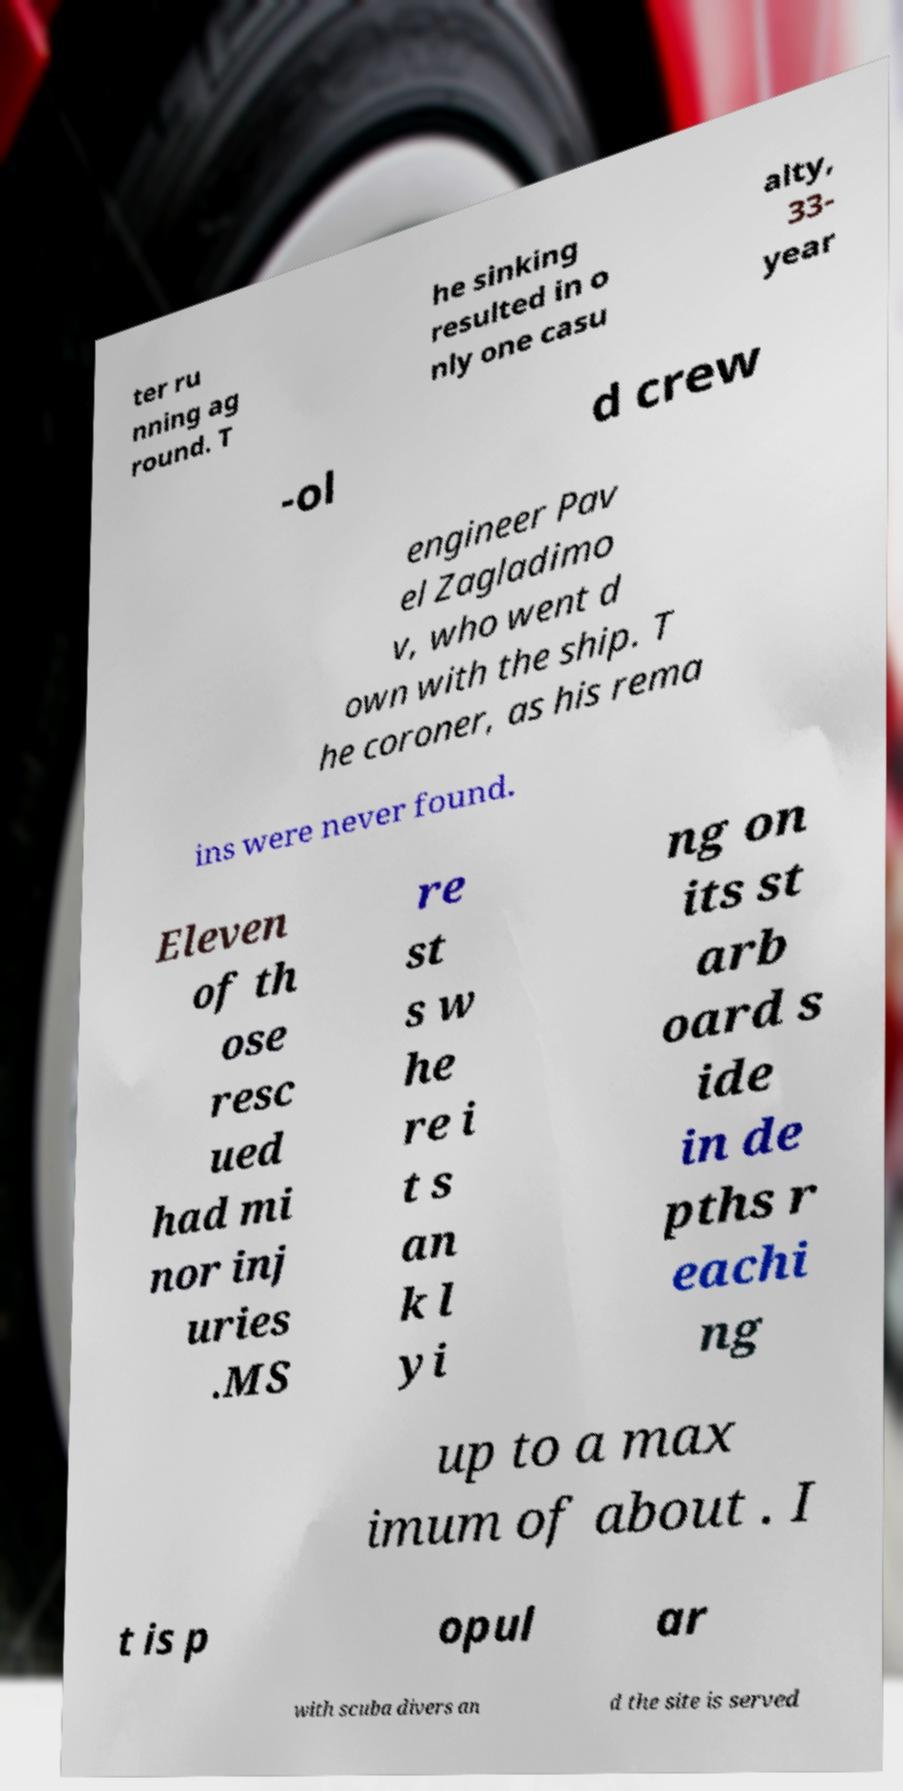Please read and relay the text visible in this image. What does it say? ter ru nning ag round. T he sinking resulted in o nly one casu alty, 33- year -ol d crew engineer Pav el Zagladimo v, who went d own with the ship. T he coroner, as his rema ins were never found. Eleven of th ose resc ued had mi nor inj uries .MS re st s w he re i t s an k l yi ng on its st arb oard s ide in de pths r eachi ng up to a max imum of about . I t is p opul ar with scuba divers an d the site is served 